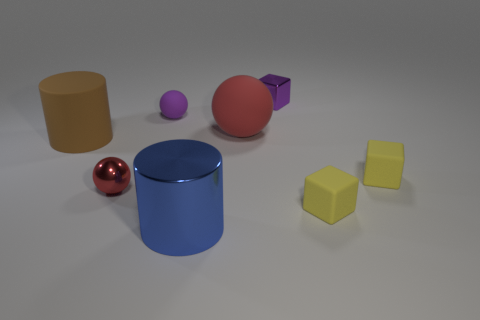Subtract all rubber balls. How many balls are left? 1 Subtract all purple cubes. How many cubes are left? 2 Add 2 big blue metal objects. How many objects exist? 10 Subtract 0 green spheres. How many objects are left? 8 Subtract all balls. How many objects are left? 5 Subtract 3 blocks. How many blocks are left? 0 Subtract all blue cylinders. Subtract all blue blocks. How many cylinders are left? 1 Subtract all red cylinders. How many brown balls are left? 0 Subtract all tiny yellow metallic spheres. Subtract all purple metallic things. How many objects are left? 7 Add 2 rubber cylinders. How many rubber cylinders are left? 3 